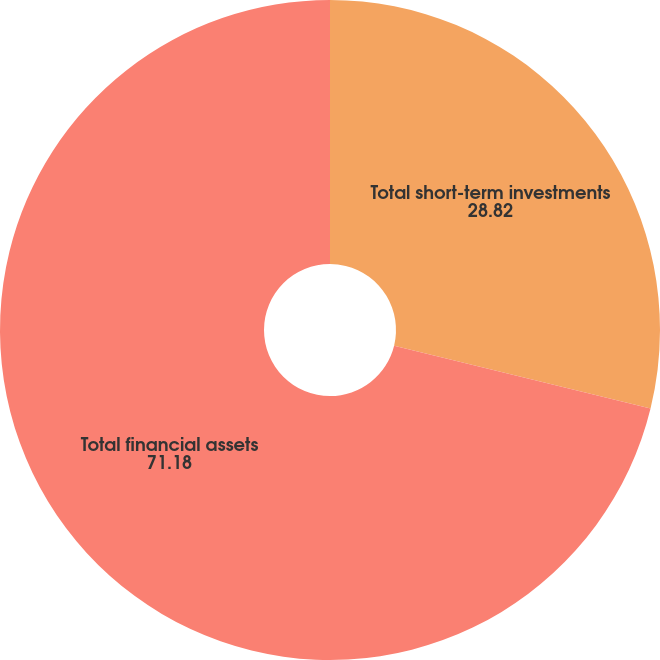<chart> <loc_0><loc_0><loc_500><loc_500><pie_chart><fcel>Total short-term investments<fcel>Total financial assets<nl><fcel>28.82%<fcel>71.18%<nl></chart> 